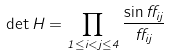Convert formula to latex. <formula><loc_0><loc_0><loc_500><loc_500>\det H = \prod _ { 1 \leq i < j \leq 4 } \frac { \sin { \alpha _ { i j } } } { \alpha _ { i j } }</formula> 